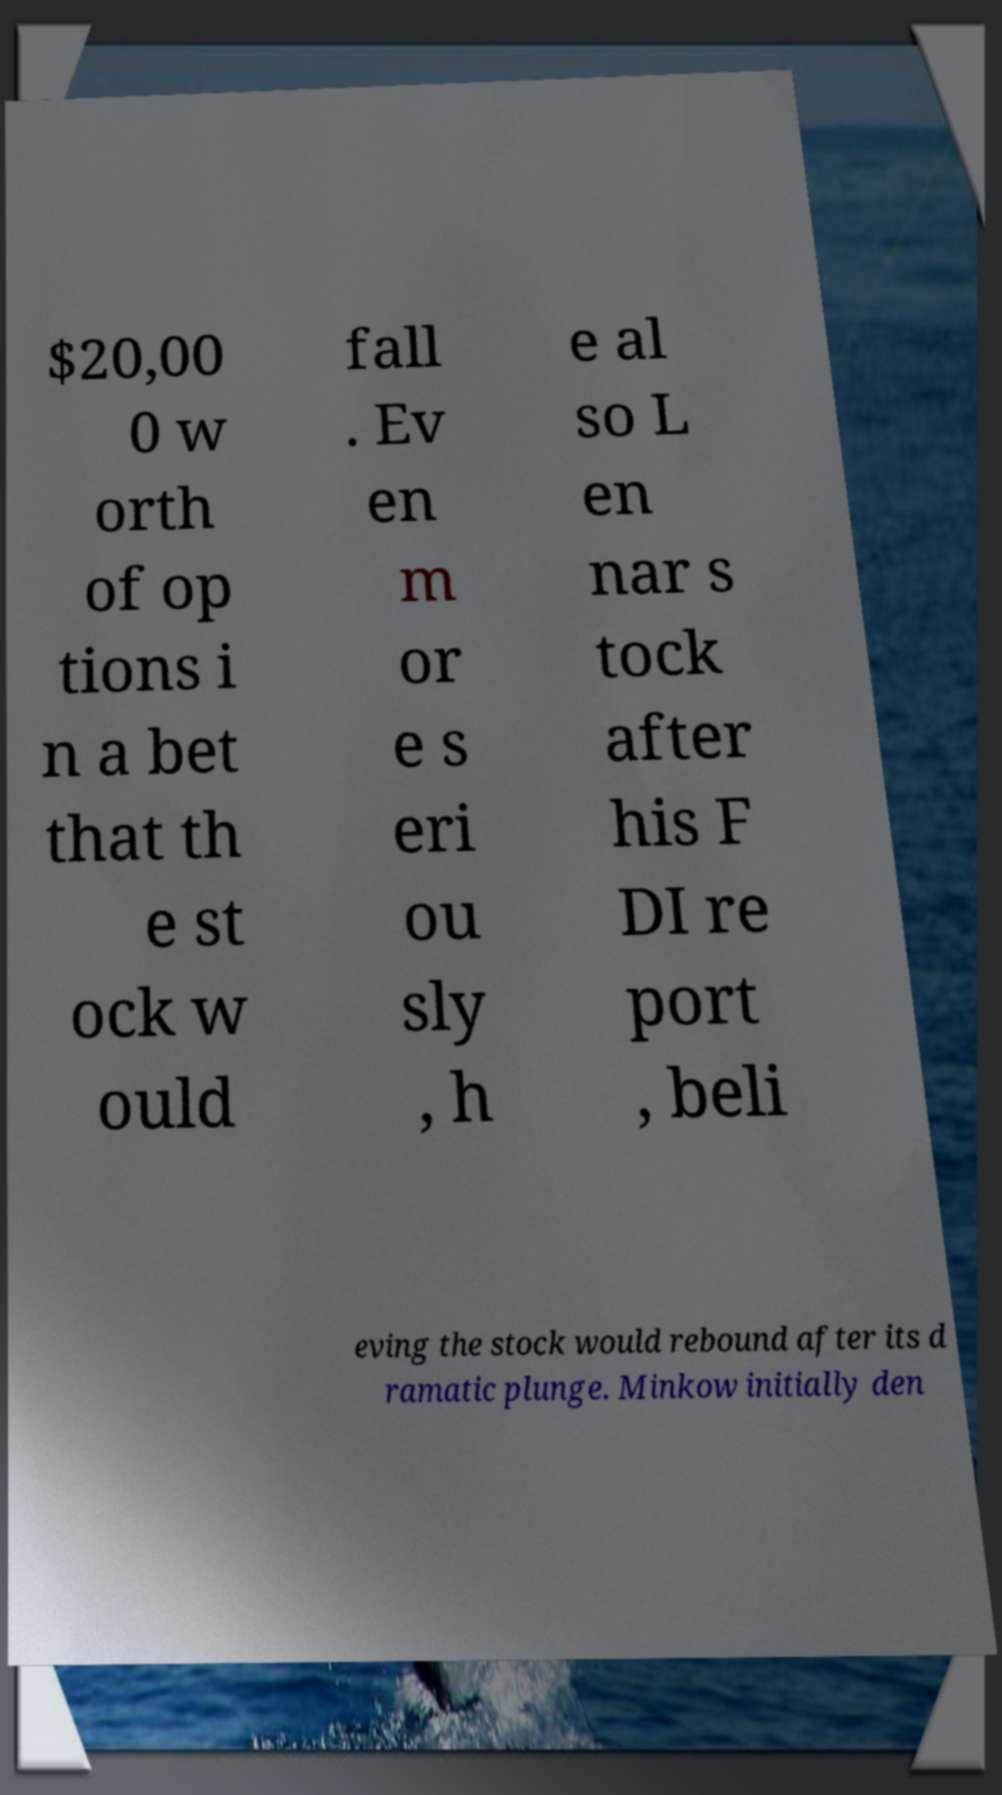What messages or text are displayed in this image? I need them in a readable, typed format. $20,00 0 w orth of op tions i n a bet that th e st ock w ould fall . Ev en m or e s eri ou sly , h e al so L en nar s tock after his F DI re port , beli eving the stock would rebound after its d ramatic plunge. Minkow initially den 